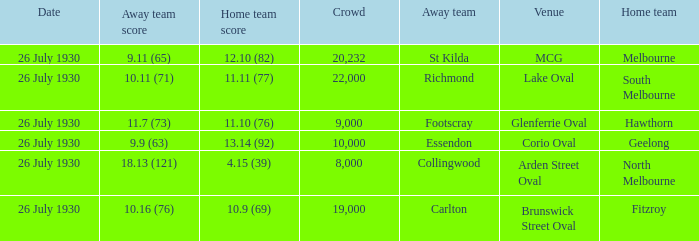Where did Geelong play a home game? Corio Oval. 